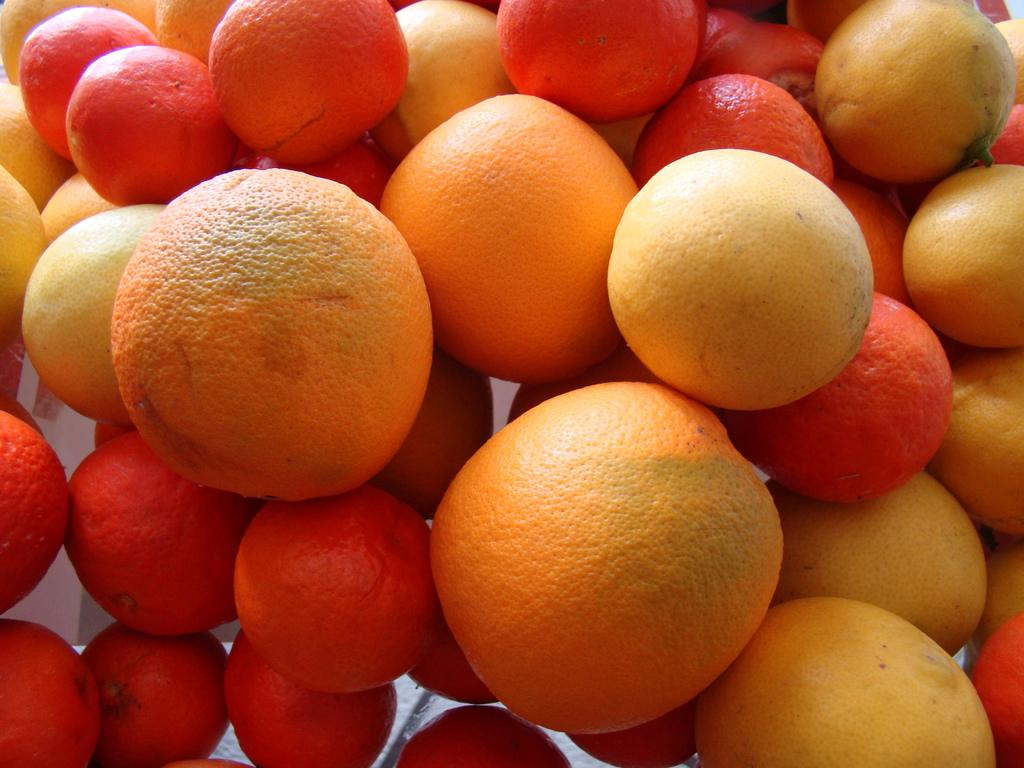What type of food is visible in the image? There are fruits in the image. How many trucks can be seen carrying grapes in the wilderness in the image? There are no trucks, grapes, or wilderness present in the image; it only features fruits. 